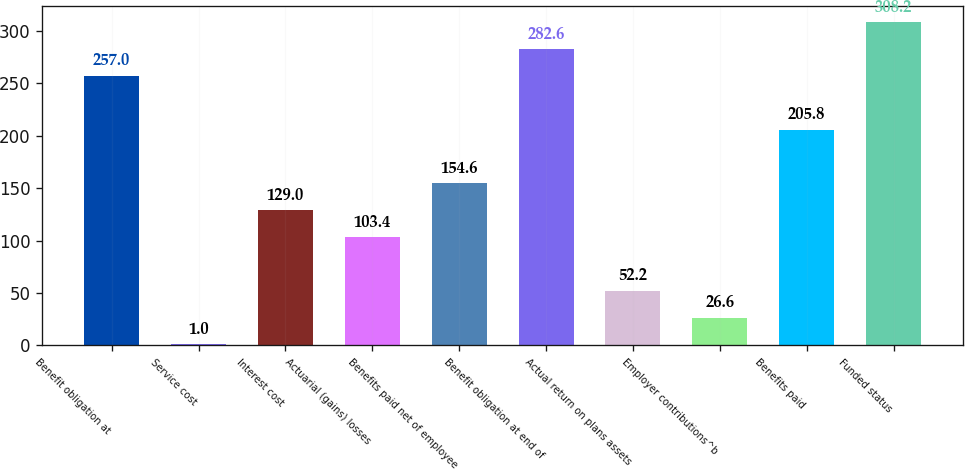Convert chart to OTSL. <chart><loc_0><loc_0><loc_500><loc_500><bar_chart><fcel>Benefit obligation at<fcel>Service cost<fcel>Interest cost<fcel>Actuarial (gains) losses<fcel>Benefits paid net of employee<fcel>Benefit obligation at end of<fcel>Actual return on plans assets<fcel>Employer contributions^b<fcel>Benefits paid<fcel>Funded status<nl><fcel>257<fcel>1<fcel>129<fcel>103.4<fcel>154.6<fcel>282.6<fcel>52.2<fcel>26.6<fcel>205.8<fcel>308.2<nl></chart> 